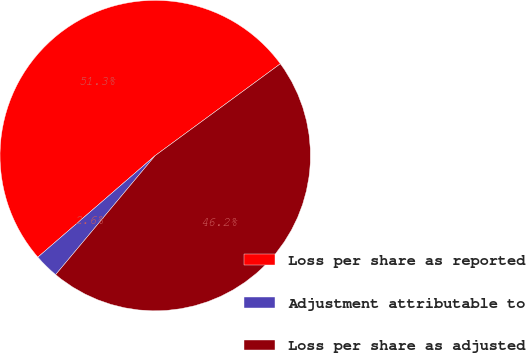Convert chart. <chart><loc_0><loc_0><loc_500><loc_500><pie_chart><fcel>Loss per share as reported<fcel>Adjustment attributable to<fcel>Loss per share as adjusted<nl><fcel>51.28%<fcel>2.56%<fcel>46.15%<nl></chart> 